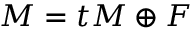<formula> <loc_0><loc_0><loc_500><loc_500>M = t M \oplus F</formula> 